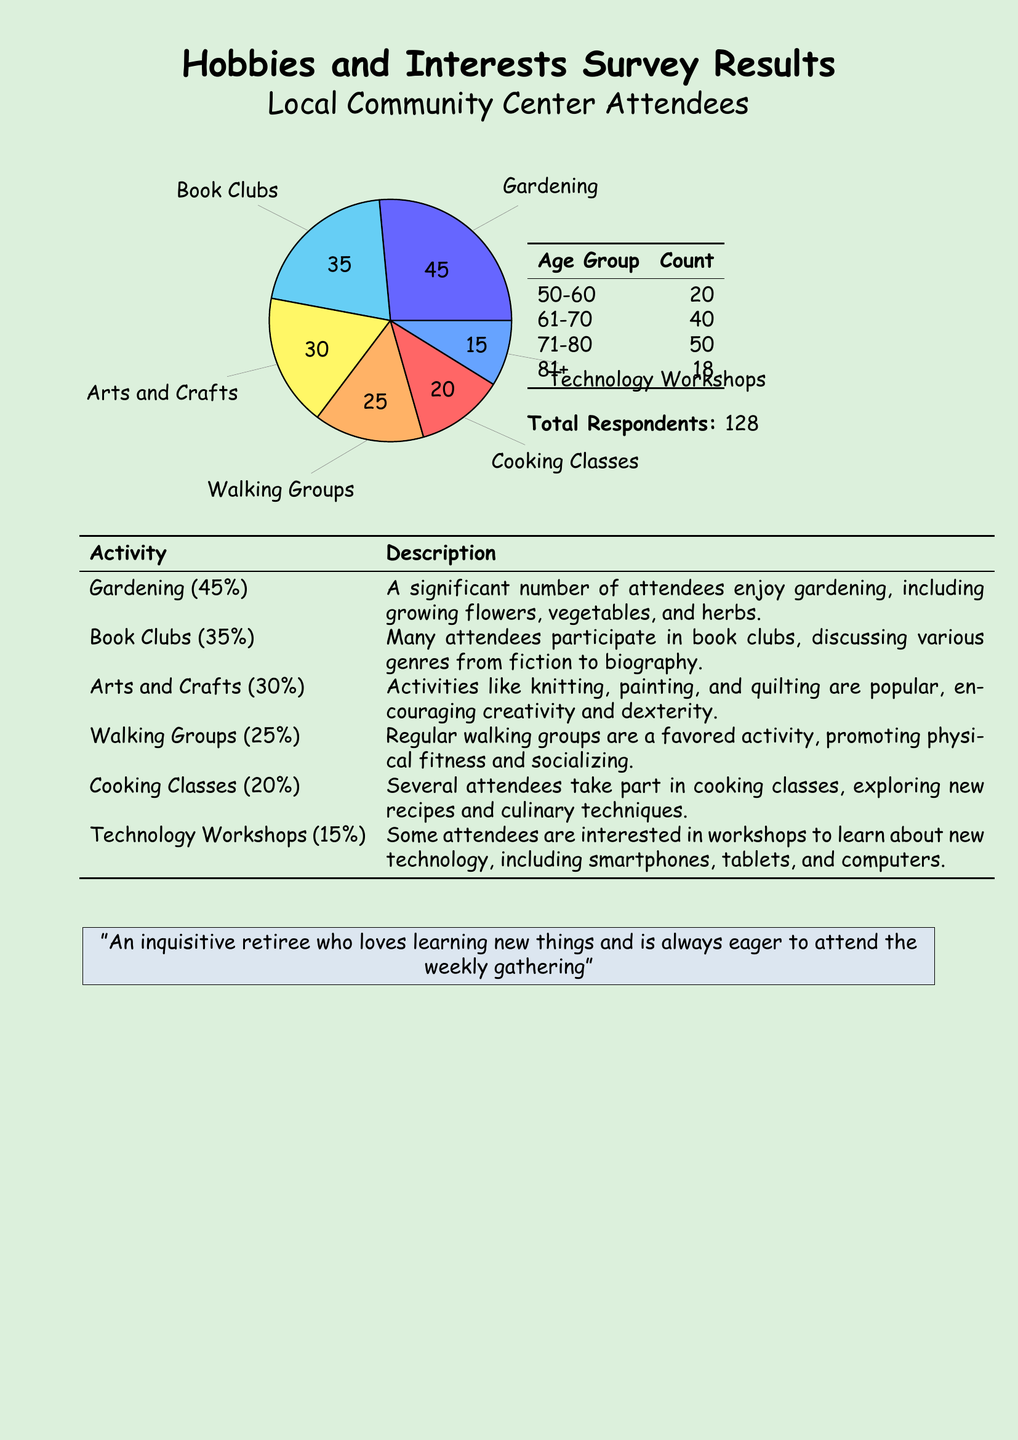What is the most popular activity? The most popular activity is identified from the pie chart, which shows gardening at 45%.
Answer: Gardening How many people participated in the survey? The total number of respondents in the survey is listed below the age group table.
Answer: 128 Which age group has the highest count? The age group with the highest count is indicated in the age group table.
Answer: 71-80 What percentage of attendees enjoys cooking classes? The percentage for cooking classes is provided in the activity description table.
Answer: 20% How many attendees are in the 61-70 age group? The specific count is detailed in the table showing age group distribution.
Answer: 40 What activity has the least interest based on the survey? The activity with the least interest can be determined from the description table and their respective percentages.
Answer: Technology Workshops What is the combined percentage of people interested in Walking Groups and Cooking Classes? The combined percentage is calculated by adding the individual percentages found in the activity description.
Answer: 45% What type of workshops are offered for those interested in technology? The specific type of workshops is stated in the activity description table.
Answer: Technology Workshops 